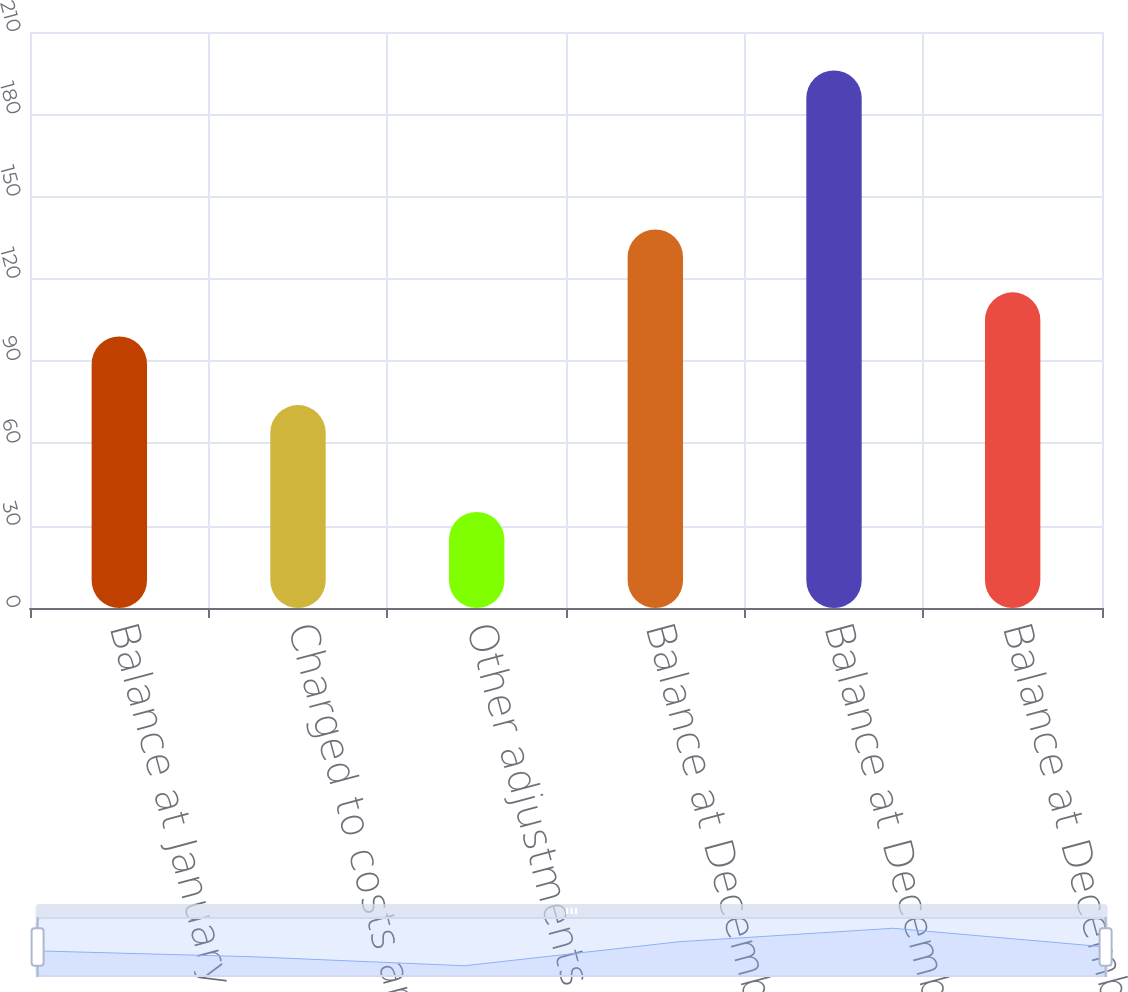<chart> <loc_0><loc_0><loc_500><loc_500><bar_chart><fcel>Balance at January 1 2016<fcel>Charged to costs and expenses<fcel>Other adjustments<fcel>Balance at December 31 2016<fcel>Balance at December 31 2017<fcel>Balance at December 31 2018<nl><fcel>99<fcel>74<fcel>35<fcel>138<fcel>196<fcel>115.1<nl></chart> 